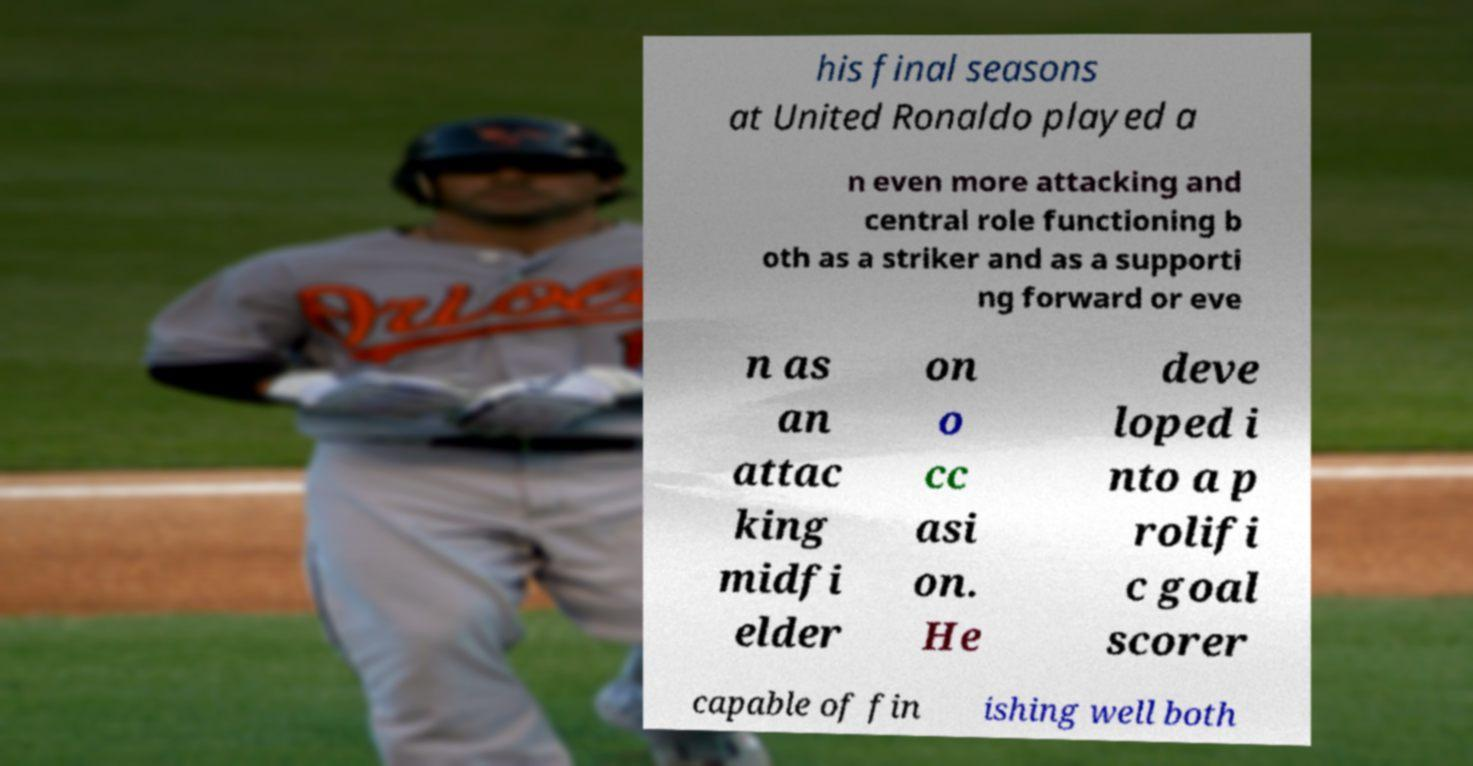For documentation purposes, I need the text within this image transcribed. Could you provide that? his final seasons at United Ronaldo played a n even more attacking and central role functioning b oth as a striker and as a supporti ng forward or eve n as an attac king midfi elder on o cc asi on. He deve loped i nto a p rolifi c goal scorer capable of fin ishing well both 